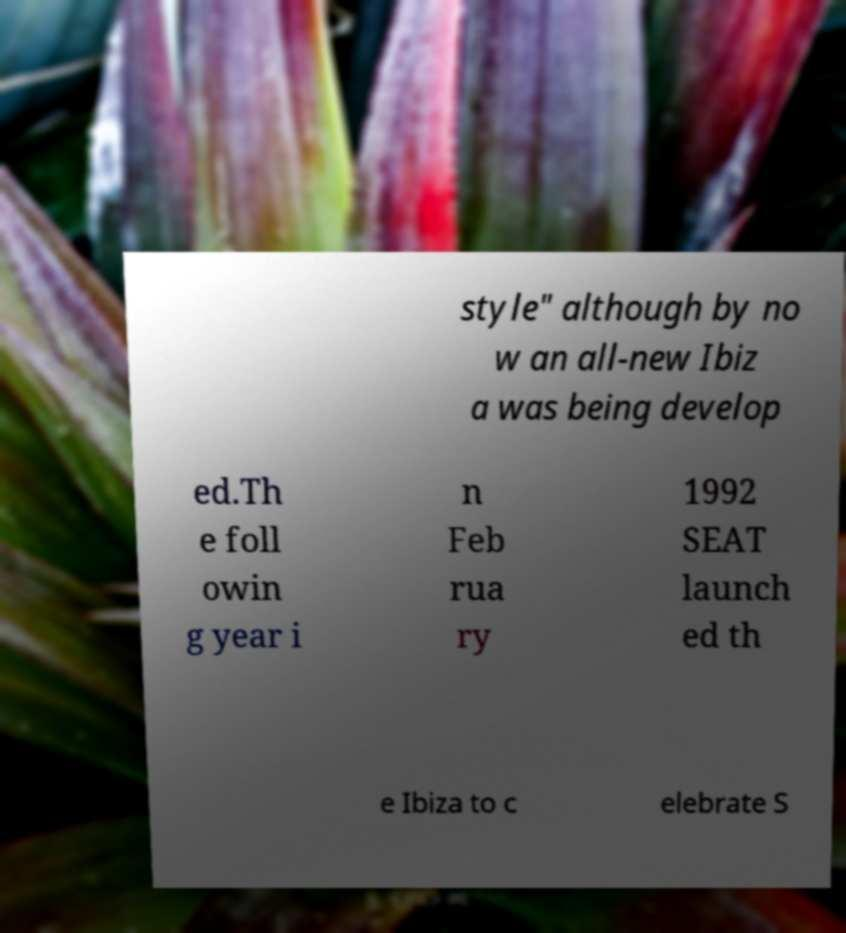Please read and relay the text visible in this image. What does it say? style" although by no w an all-new Ibiz a was being develop ed.Th e foll owin g year i n Feb rua ry 1992 SEAT launch ed th e Ibiza to c elebrate S 